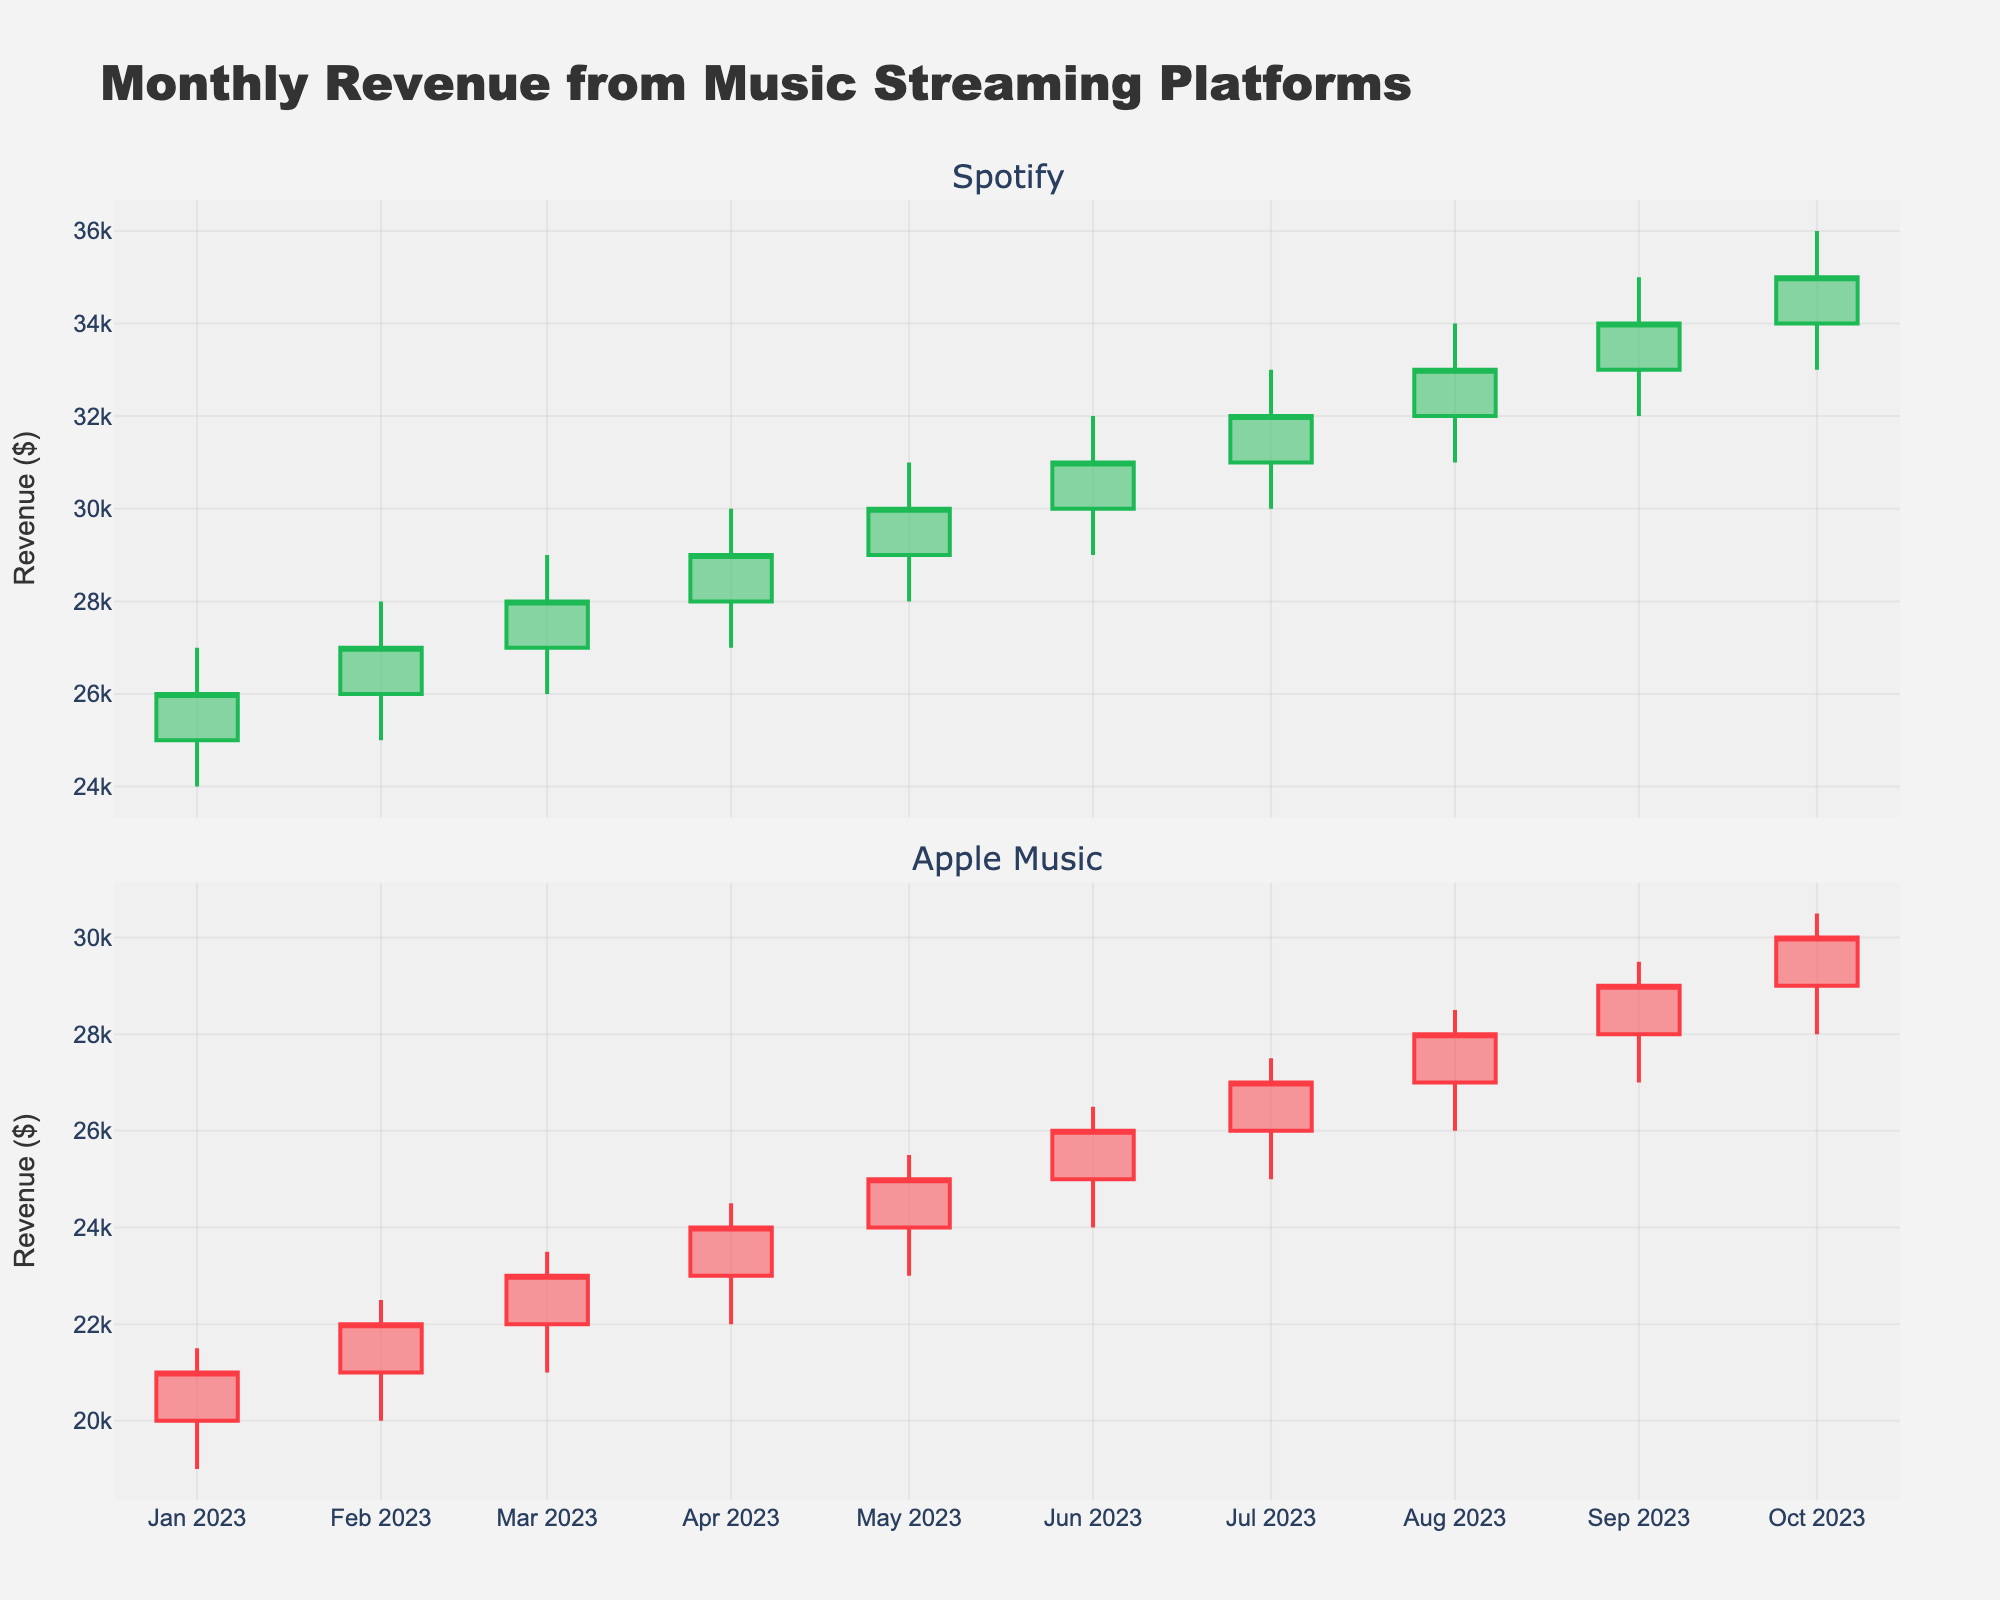what is the title of the figure? The title is usually located above the main part of the plot and provides a brief description of what the plot represents. In this figure, the title is clearly mentioned at the top center.
Answer: Monthly Revenue from Music Streaming Platforms which month's revenue for Spotify saw the highest closing value? To find this, we look at the candlestick plot for Spotify and identify the month where the top of the candlestick body (the closing value) is the highest. The plot shows that the highest closing value is in October 2023 at $35,000.
Answer: October 2023 how does Spotify's revenue trend compare to Apple Music from June to October? To compare trends, examine the direction and magnitude of changes from June to October for both platforms. From June to October, Spotify's revenue increases from $31,000 to $35,000, while Apple Music's revenue increases from $26,000 to $30,000. Both show an upward trend, but Spotify has a higher increase in revenue.
Answer: Both increased, but Spotify had a higher increase what was the lowest revenue for Apple Music observed in the plot? To determine this, look for the lowest point in any of the candlestick wicks for Apple Music. The plot indicates that the lowest revenue observed for Apple Music was $19,000 in January 2023.
Answer: $19,000 which platform had a higher revenue in March 2023? Compare the closing values of both platforms in March 2023. For March 2023, Spotify's closing value is $28,000, and Apple Music's closing value is $23,000. Therefore, Spotify had a higher revenue in March 2023.
Answer: Spotify what is the average closing value for Spotify from January to October? To find the average, sum the closing values for all months from January to October and then divide by the number of months (10). The closing values are 26000 + 27000 + 28000 + 29000 + 30000 + 31000 + 32000 + 33000 + 34000 + 35000. The sum is 325000, and the average is 325000/10 = 32500.
Answer: $32,500 which month's revenue for Spotify had the largest difference between the high and low values? The difference between the high and low values for each month is the range. Calculate the range for each month and find the month with the largest range. For Spotify, July 2023 has the largest range: 33000 - 30000 = 3000.
Answer: July 2023 did Apple Music or Spotify close higher on average each month? To find out, calculate the average closing value for both platforms from January to October. The average for Spotify is $32,500, and for Apple Music, sum the closing values: 21000 + 22000 + 23000 + 24000 + 25000 + 26000 + 27000 + 28000 + 29000 + 30000. The sum is 255000, and the average is 255000/10 = 25500. Thus, Spotify closed higher on average each month.
Answer: Spotify which platform showed more consistent monthly growth from January to October? Consistency in growth can be gauged by stability in the increase of closing values over months. By observing both plots, Spotify shows a consistent steady increase each month, more so than Apple Music which also consistently grows but with slightly more variation.
Answer: Spotify 